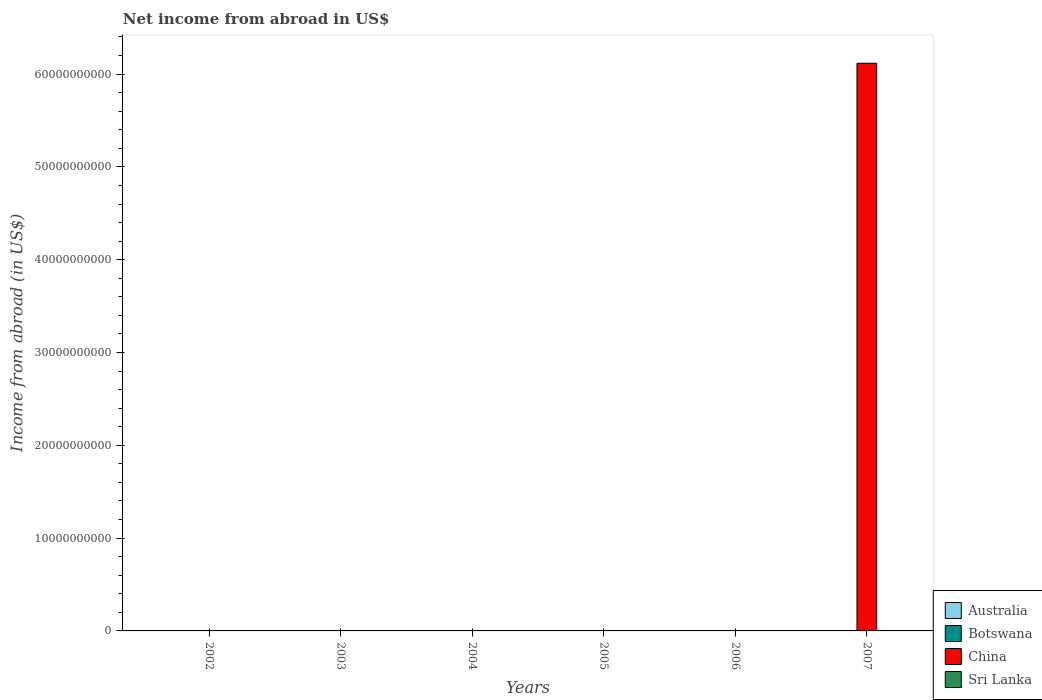How many different coloured bars are there?
Provide a succinct answer. 1. Are the number of bars on each tick of the X-axis equal?
Your answer should be very brief. No. How many bars are there on the 5th tick from the left?
Your answer should be compact. 0. In how many cases, is the number of bars for a given year not equal to the number of legend labels?
Provide a succinct answer. 6. What is the net income from abroad in China in 2007?
Make the answer very short. 6.12e+1. Across all years, what is the maximum net income from abroad in China?
Your answer should be compact. 6.12e+1. What is the total net income from abroad in Sri Lanka in the graph?
Ensure brevity in your answer.  0. What is the average net income from abroad in China per year?
Keep it short and to the point. 1.02e+1. What is the difference between the highest and the lowest net income from abroad in China?
Offer a very short reply. 6.12e+1. Are all the bars in the graph horizontal?
Give a very brief answer. No. Are the values on the major ticks of Y-axis written in scientific E-notation?
Your response must be concise. No. How many legend labels are there?
Offer a terse response. 4. What is the title of the graph?
Make the answer very short. Net income from abroad in US$. Does "El Salvador" appear as one of the legend labels in the graph?
Offer a very short reply. No. What is the label or title of the Y-axis?
Keep it short and to the point. Income from abroad (in US$). What is the Income from abroad (in US$) of Australia in 2002?
Make the answer very short. 0. What is the Income from abroad (in US$) in China in 2002?
Provide a succinct answer. 0. What is the Income from abroad (in US$) in Sri Lanka in 2002?
Your response must be concise. 0. What is the Income from abroad (in US$) of Botswana in 2003?
Keep it short and to the point. 0. What is the Income from abroad (in US$) of China in 2003?
Provide a short and direct response. 0. What is the Income from abroad (in US$) in Sri Lanka in 2003?
Your answer should be very brief. 0. What is the Income from abroad (in US$) in China in 2004?
Your answer should be compact. 0. What is the Income from abroad (in US$) in Sri Lanka in 2004?
Your answer should be compact. 0. What is the Income from abroad (in US$) of Australia in 2005?
Offer a very short reply. 0. What is the Income from abroad (in US$) of China in 2005?
Offer a very short reply. 0. What is the Income from abroad (in US$) in Sri Lanka in 2005?
Provide a short and direct response. 0. What is the Income from abroad (in US$) of Sri Lanka in 2006?
Give a very brief answer. 0. What is the Income from abroad (in US$) of Botswana in 2007?
Provide a short and direct response. 0. What is the Income from abroad (in US$) in China in 2007?
Offer a terse response. 6.12e+1. What is the Income from abroad (in US$) of Sri Lanka in 2007?
Your answer should be very brief. 0. Across all years, what is the maximum Income from abroad (in US$) of China?
Provide a short and direct response. 6.12e+1. What is the total Income from abroad (in US$) in Australia in the graph?
Your answer should be very brief. 0. What is the total Income from abroad (in US$) of China in the graph?
Your response must be concise. 6.12e+1. What is the total Income from abroad (in US$) of Sri Lanka in the graph?
Offer a terse response. 0. What is the average Income from abroad (in US$) of Australia per year?
Provide a short and direct response. 0. What is the average Income from abroad (in US$) of China per year?
Make the answer very short. 1.02e+1. What is the difference between the highest and the lowest Income from abroad (in US$) of China?
Ensure brevity in your answer.  6.12e+1. 